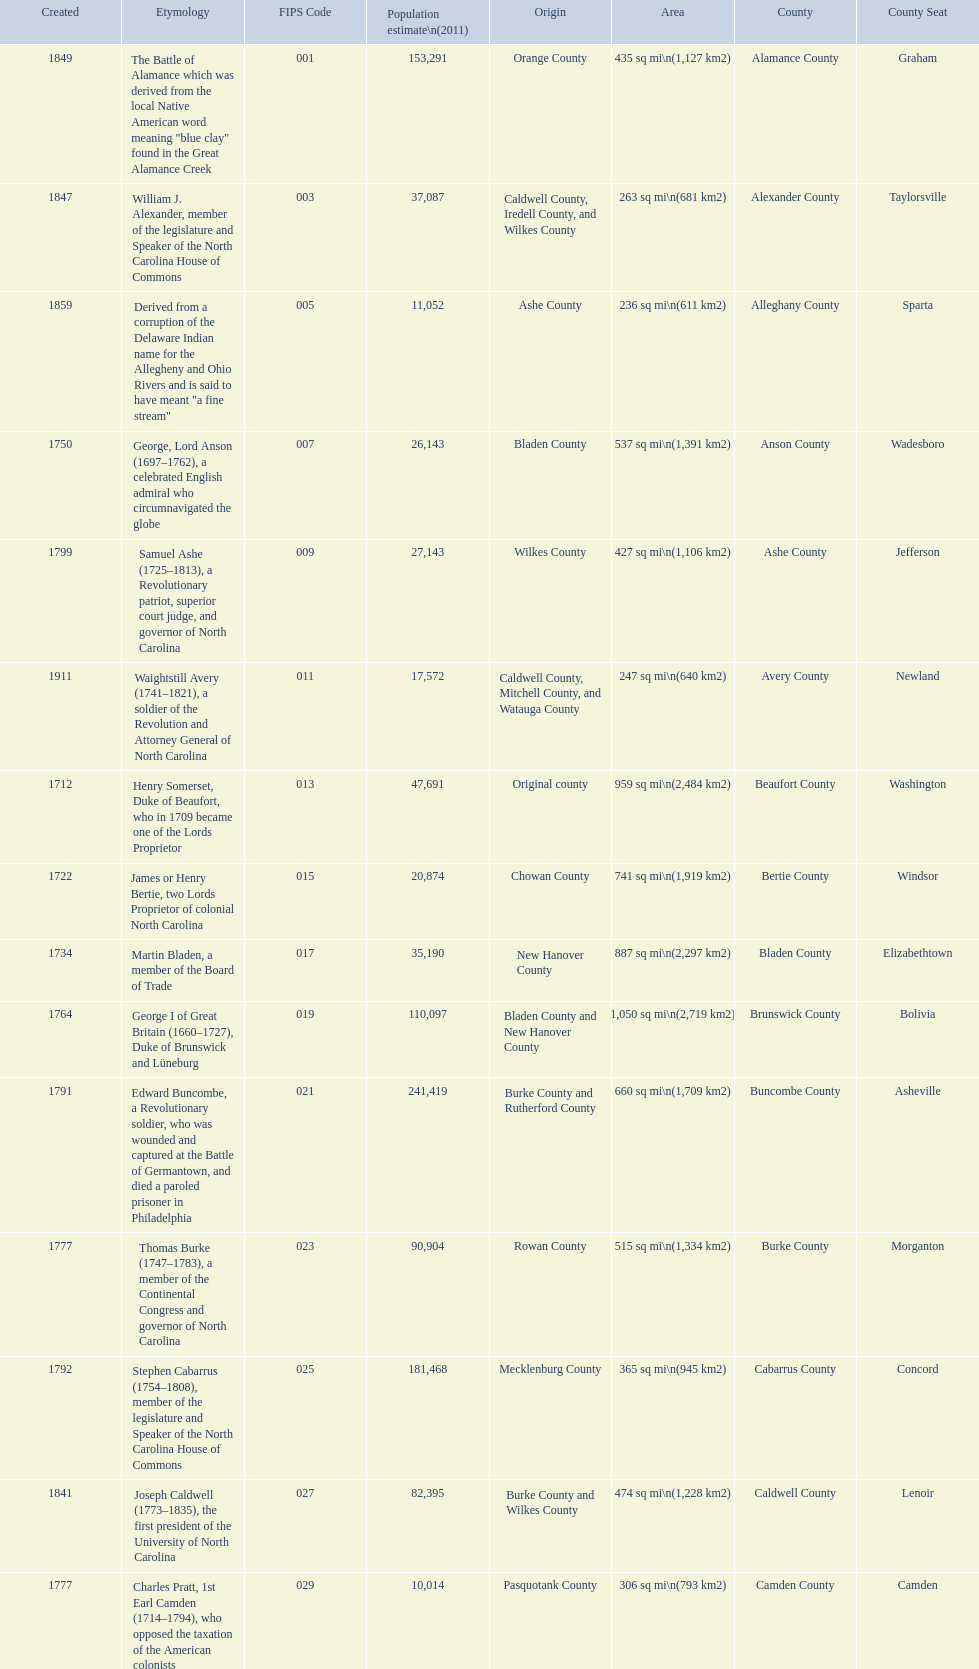What is the number of counties created in the 1800s? 37. 